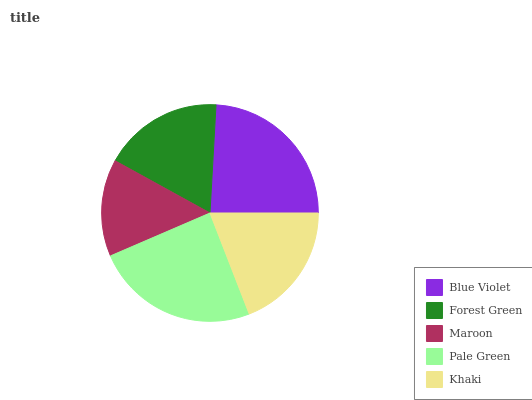Is Maroon the minimum?
Answer yes or no. Yes. Is Pale Green the maximum?
Answer yes or no. Yes. Is Forest Green the minimum?
Answer yes or no. No. Is Forest Green the maximum?
Answer yes or no. No. Is Blue Violet greater than Forest Green?
Answer yes or no. Yes. Is Forest Green less than Blue Violet?
Answer yes or no. Yes. Is Forest Green greater than Blue Violet?
Answer yes or no. No. Is Blue Violet less than Forest Green?
Answer yes or no. No. Is Khaki the high median?
Answer yes or no. Yes. Is Khaki the low median?
Answer yes or no. Yes. Is Forest Green the high median?
Answer yes or no. No. Is Maroon the low median?
Answer yes or no. No. 